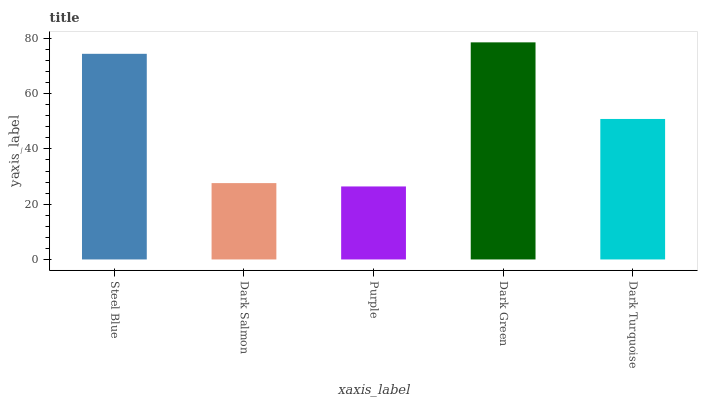Is Dark Salmon the minimum?
Answer yes or no. No. Is Dark Salmon the maximum?
Answer yes or no. No. Is Steel Blue greater than Dark Salmon?
Answer yes or no. Yes. Is Dark Salmon less than Steel Blue?
Answer yes or no. Yes. Is Dark Salmon greater than Steel Blue?
Answer yes or no. No. Is Steel Blue less than Dark Salmon?
Answer yes or no. No. Is Dark Turquoise the high median?
Answer yes or no. Yes. Is Dark Turquoise the low median?
Answer yes or no. Yes. Is Dark Salmon the high median?
Answer yes or no. No. Is Dark Green the low median?
Answer yes or no. No. 